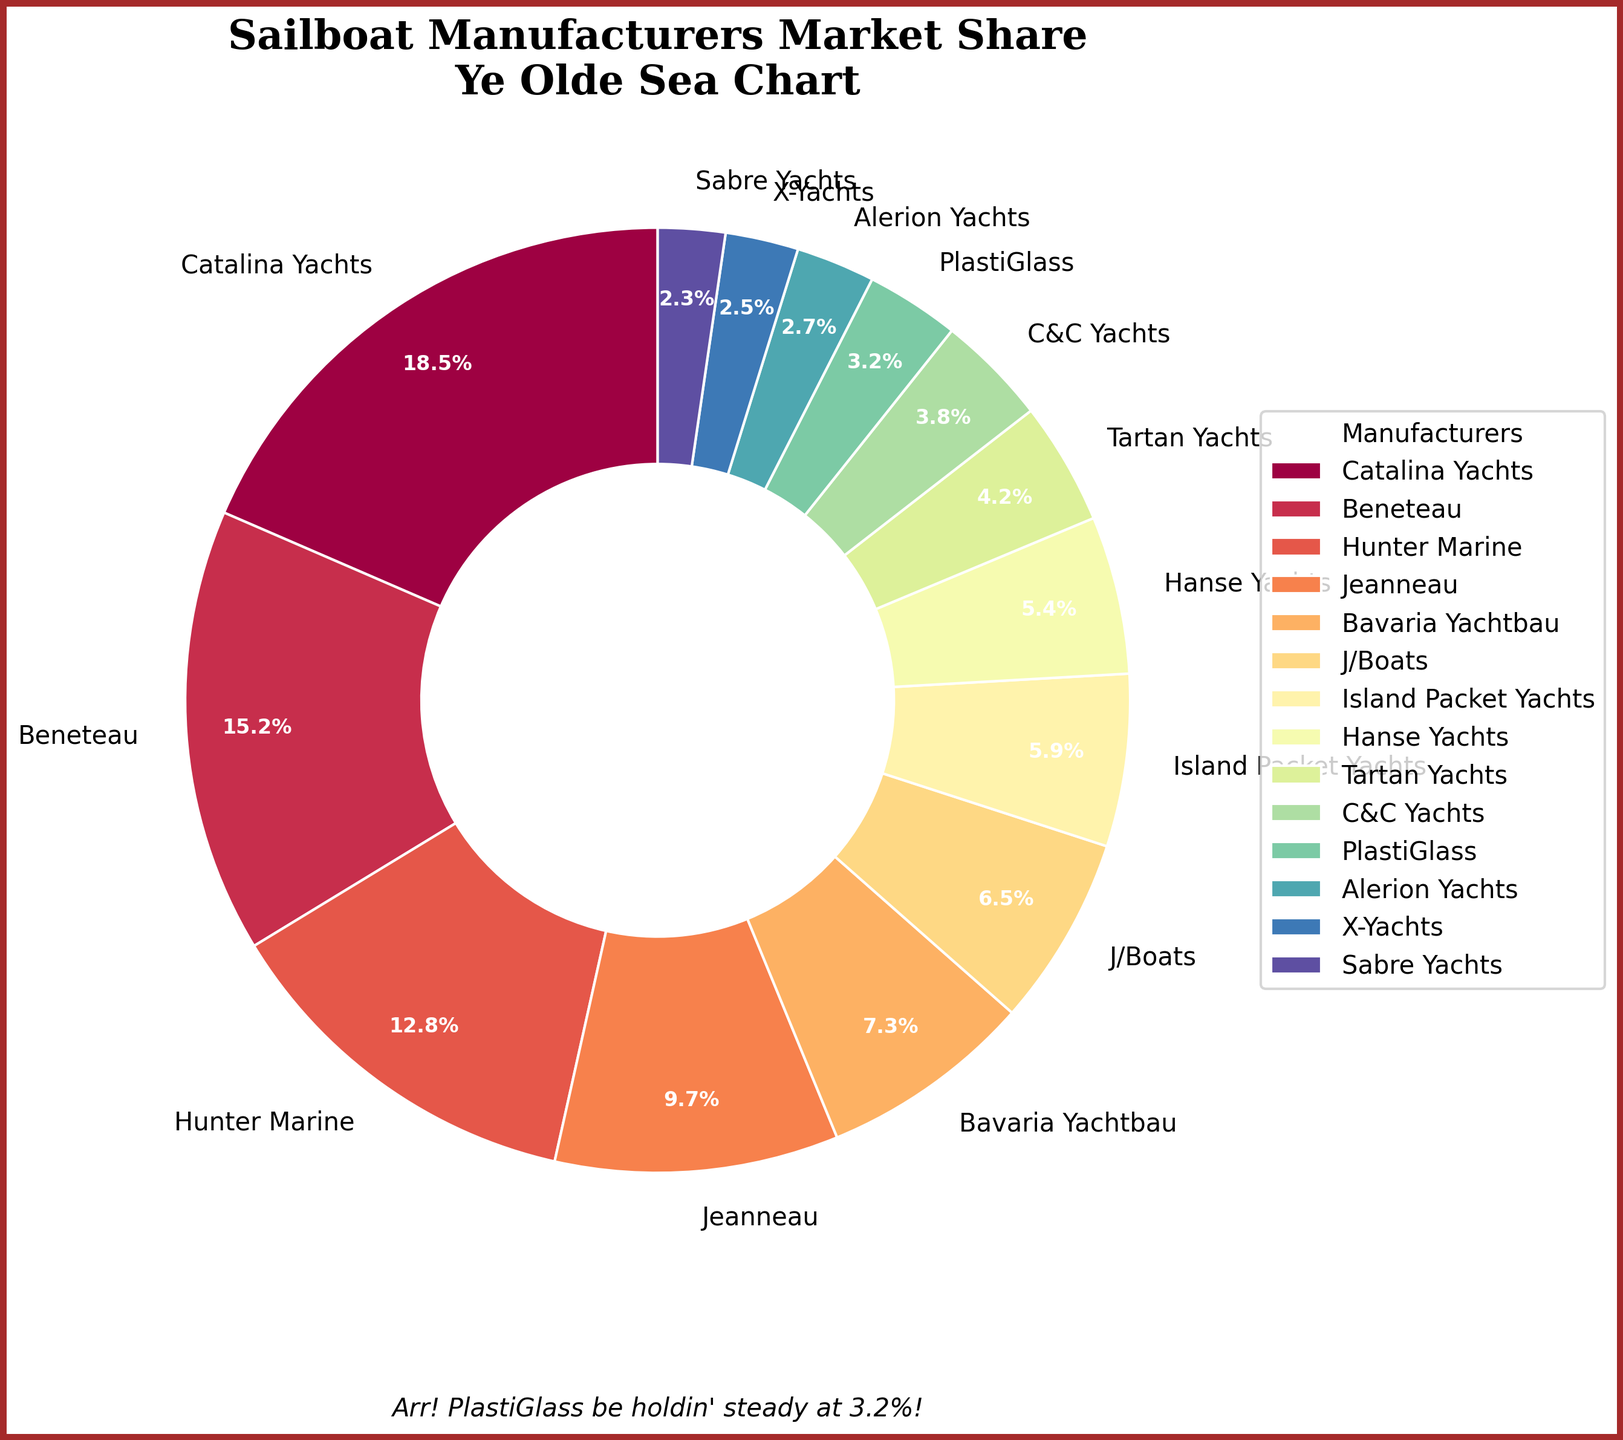Which manufacturer has the highest market share? The chart shows the market share distribution among sailboat manufacturers, and the slice with the largest percentage represents the manufacturer with the highest market share. Catalina Yachts has the largest slice with 18.5%.
Answer: Catalina Yachts What is the combined market share of Beneteau and Jeanneau? Locate the slices for Beneteau and Jeanneau in the pie chart. Beneteau has 15.2% and Jeanneau has 9.7%. Add these two percentages together: 15.2 + 9.7 = 24.9.
Answer: 24.9% How does the market share of Hunter Marine compare to Bavaria Yachtbau? Find the slices for Hunter Marine and Bavaria Yachtbau on the pie chart. Hunter Marine has a market share of 12.8%, and Bavaria Yachtbau has 7.3%. 12.8% is greater than 7.3%.
Answer: Hunter Marine's market share is greater than Bavaria Yachtbau's Which manufacturer holds the smallest market share? Identify the smallest slice on the pie chart. Sabre Yachts has the smallest market share at 2.3%.
Answer: Sabre Yachts What is the total market share of manufacturers with less than 5% market share? Identify slices with less than 5%: Tartan Yachts (4.2%), C&C Yachts (3.8%), PlastiGlass (3.2%), Alerion Yachts (2.7%), X-Yachts (2.5%), and Sabre Yachts (2.3%). Sum these percentages: 4.2 + 3.8 + 3.2 + 2.7 + 2.5 + 2.3 = 18.7.
Answer: 18.7% Which two manufacturers have a combined market share closest to 20%? Look at the slices and find pairs of manufacturers whose percentages add up to about 20%. Catalina Yachts (18.5%) and PlastiGlass (3.2%) combined market share is 21.7%. Beneteau (15.2%) and Island Packet Yachts (5.9%) combined market share is 21.1%. Beneteau (15.2%) and Hanse Yachts (5.4%) combined market share is 20.6%. Beneteau (15.2%) and J/Boats (6.5%) combined market share is 21.7%. None are exactly 20%, but Beneteau and Hanse Yachts are closest.
Answer: Beneteau and Hanse Yachts Which color represents J/Boats on the pie chart? Identify the segment labeled "J/Boats" and observe its color. J/Boats is represented by a slice colored deep orange.
Answer: Deep orange What is the difference in market share between Catalina Yachts and Hunter Marine? Refer to the slices, Catalina Yachts holds 18.5% and Hunter Marine holds 12.8%. Calculate the difference: 18.5 - 12.8 = 5.7.
Answer: 5.7% Which manufacturers have market shares within 1% of each other? Look for segments with similar sizes close to 1% difference. J/Boats (6.5%) and Island Packet Yachts (5.9%) differ by 0.6%. Hanse Yachts (5.4%) and Tartan Yachts (4.2%) differ by 1.2%. C&C Yachts (3.8%) and PlastiGlass (3.2%) differ by 0.6%. Alerion Yachts (2.7%) and X-Yachts (2.5%) differ by 0.2%.
Answer: Alerion Yachts and X-Yachts 